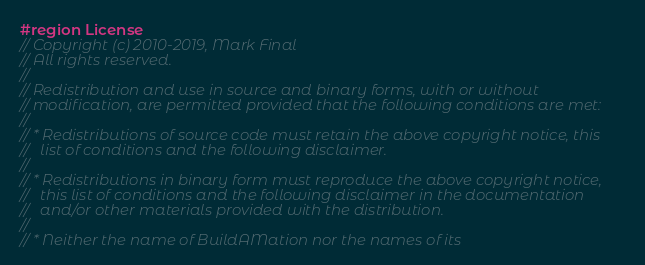Convert code to text. <code><loc_0><loc_0><loc_500><loc_500><_C#_>#region License
// Copyright (c) 2010-2019, Mark Final
// All rights reserved.
//
// Redistribution and use in source and binary forms, with or without
// modification, are permitted provided that the following conditions are met:
//
// * Redistributions of source code must retain the above copyright notice, this
//   list of conditions and the following disclaimer.
//
// * Redistributions in binary form must reproduce the above copyright notice,
//   this list of conditions and the following disclaimer in the documentation
//   and/or other materials provided with the distribution.
//
// * Neither the name of BuildAMation nor the names of its</code> 